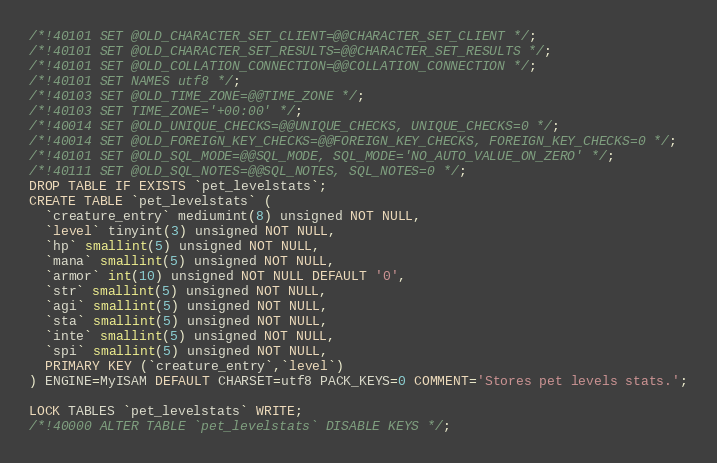Convert code to text. <code><loc_0><loc_0><loc_500><loc_500><_SQL_>
/*!40101 SET @OLD_CHARACTER_SET_CLIENT=@@CHARACTER_SET_CLIENT */;
/*!40101 SET @OLD_CHARACTER_SET_RESULTS=@@CHARACTER_SET_RESULTS */;
/*!40101 SET @OLD_COLLATION_CONNECTION=@@COLLATION_CONNECTION */;
/*!40101 SET NAMES utf8 */;
/*!40103 SET @OLD_TIME_ZONE=@@TIME_ZONE */;
/*!40103 SET TIME_ZONE='+00:00' */;
/*!40014 SET @OLD_UNIQUE_CHECKS=@@UNIQUE_CHECKS, UNIQUE_CHECKS=0 */;
/*!40014 SET @OLD_FOREIGN_KEY_CHECKS=@@FOREIGN_KEY_CHECKS, FOREIGN_KEY_CHECKS=0 */;
/*!40101 SET @OLD_SQL_MODE=@@SQL_MODE, SQL_MODE='NO_AUTO_VALUE_ON_ZERO' */;
/*!40111 SET @OLD_SQL_NOTES=@@SQL_NOTES, SQL_NOTES=0 */;
DROP TABLE IF EXISTS `pet_levelstats`;
CREATE TABLE `pet_levelstats` (
  `creature_entry` mediumint(8) unsigned NOT NULL,
  `level` tinyint(3) unsigned NOT NULL,
  `hp` smallint(5) unsigned NOT NULL,
  `mana` smallint(5) unsigned NOT NULL,
  `armor` int(10) unsigned NOT NULL DEFAULT '0',
  `str` smallint(5) unsigned NOT NULL,
  `agi` smallint(5) unsigned NOT NULL,
  `sta` smallint(5) unsigned NOT NULL,
  `inte` smallint(5) unsigned NOT NULL,
  `spi` smallint(5) unsigned NOT NULL,
  PRIMARY KEY (`creature_entry`,`level`)
) ENGINE=MyISAM DEFAULT CHARSET=utf8 PACK_KEYS=0 COMMENT='Stores pet levels stats.';

LOCK TABLES `pet_levelstats` WRITE;
/*!40000 ALTER TABLE `pet_levelstats` DISABLE KEYS */;</code> 